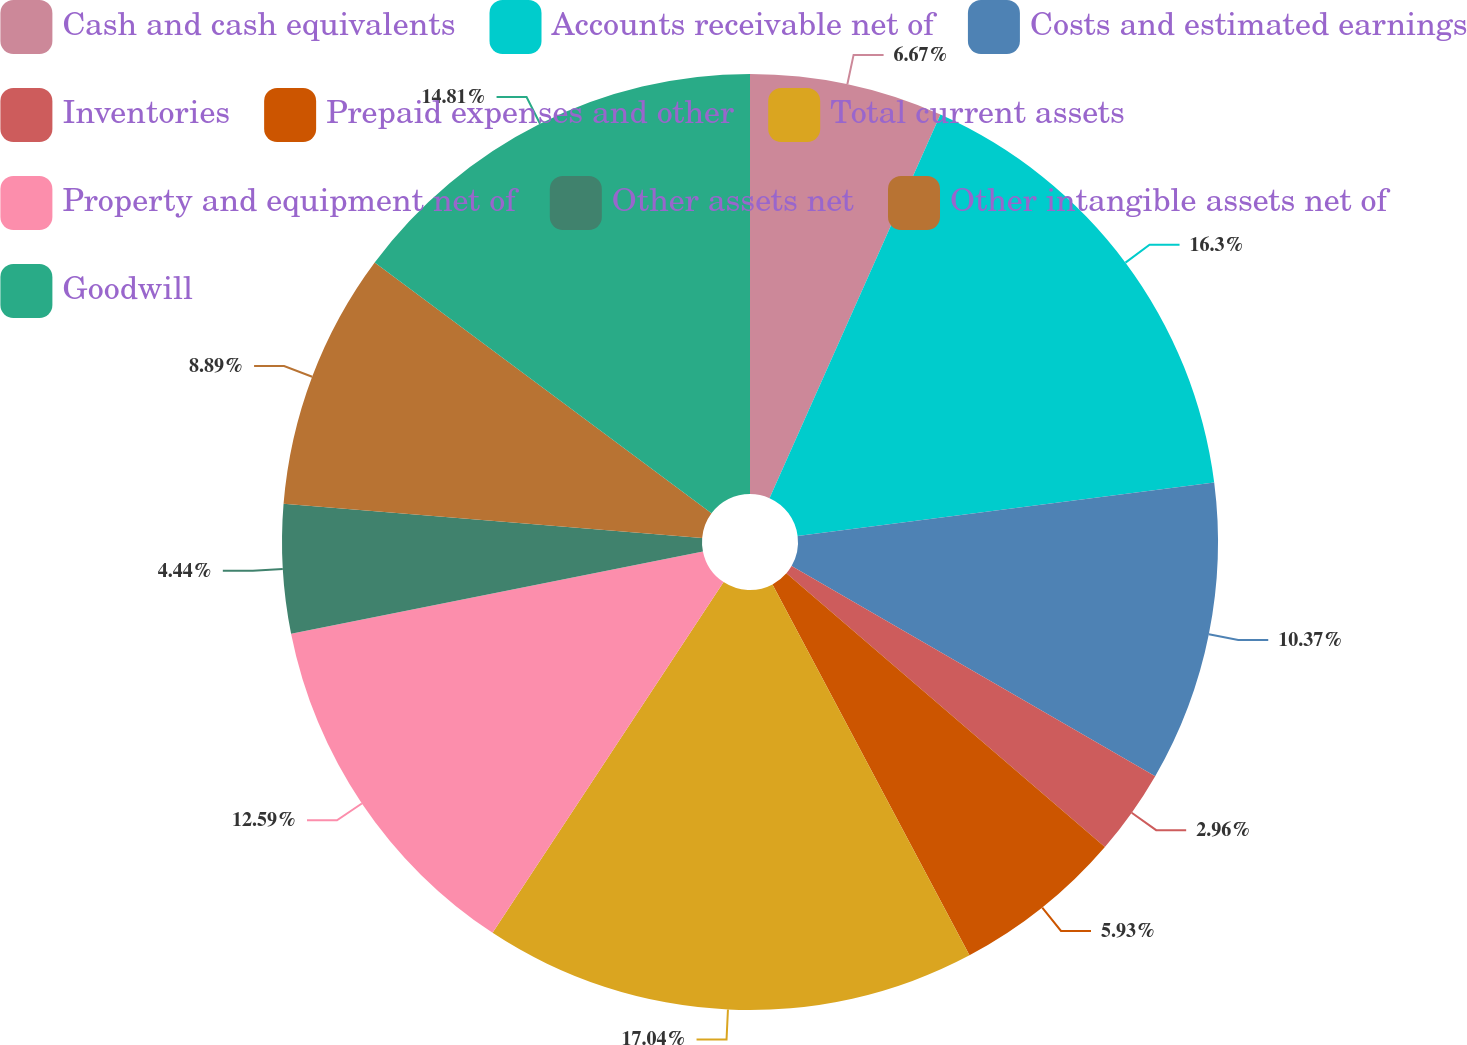Convert chart to OTSL. <chart><loc_0><loc_0><loc_500><loc_500><pie_chart><fcel>Cash and cash equivalents<fcel>Accounts receivable net of<fcel>Costs and estimated earnings<fcel>Inventories<fcel>Prepaid expenses and other<fcel>Total current assets<fcel>Property and equipment net of<fcel>Other assets net<fcel>Other intangible assets net of<fcel>Goodwill<nl><fcel>6.67%<fcel>16.3%<fcel>10.37%<fcel>2.96%<fcel>5.93%<fcel>17.04%<fcel>12.59%<fcel>4.44%<fcel>8.89%<fcel>14.81%<nl></chart> 